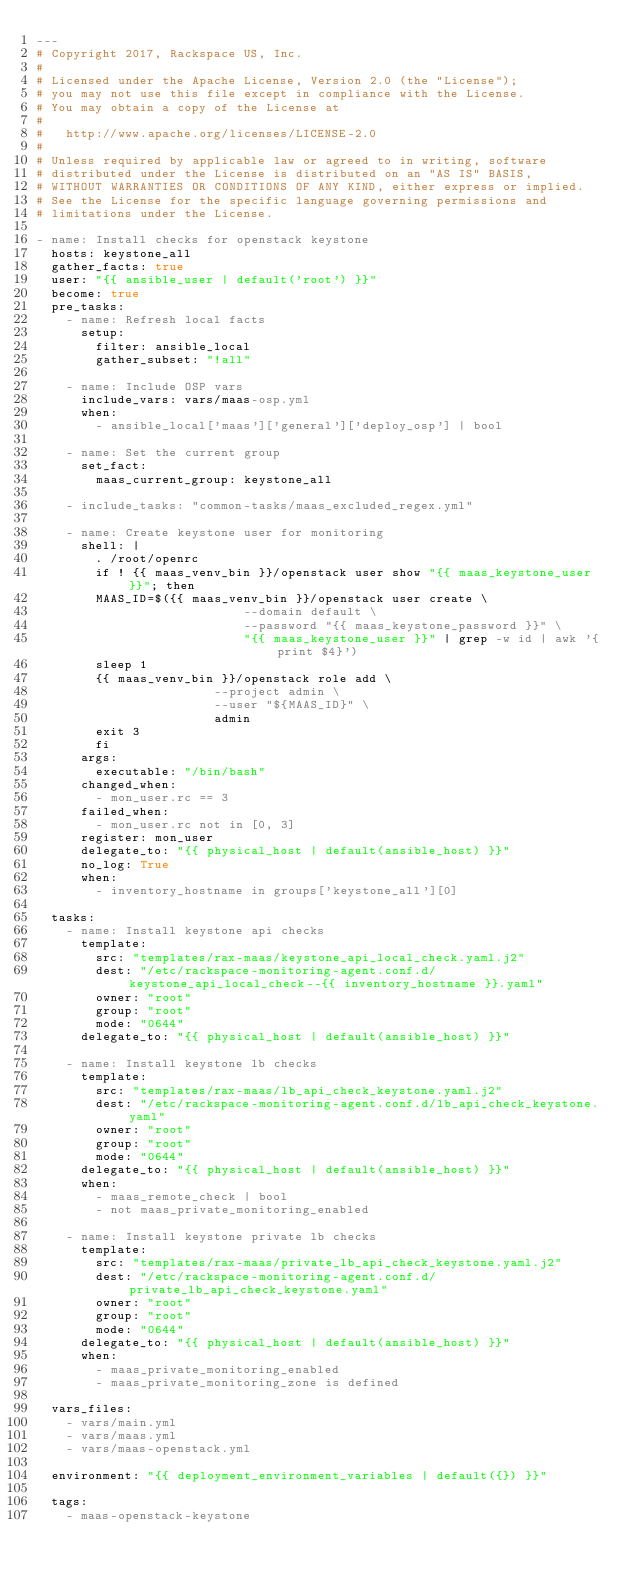Convert code to text. <code><loc_0><loc_0><loc_500><loc_500><_YAML_>---
# Copyright 2017, Rackspace US, Inc.
#
# Licensed under the Apache License, Version 2.0 (the "License");
# you may not use this file except in compliance with the License.
# You may obtain a copy of the License at
#
#   http://www.apache.org/licenses/LICENSE-2.0
#
# Unless required by applicable law or agreed to in writing, software
# distributed under the License is distributed on an "AS IS" BASIS,
# WITHOUT WARRANTIES OR CONDITIONS OF ANY KIND, either express or implied.
# See the License for the specific language governing permissions and
# limitations under the License.

- name: Install checks for openstack keystone
  hosts: keystone_all
  gather_facts: true
  user: "{{ ansible_user | default('root') }}"
  become: true
  pre_tasks:
    - name: Refresh local facts
      setup:
        filter: ansible_local
        gather_subset: "!all"

    - name: Include OSP vars
      include_vars: vars/maas-osp.yml
      when:
        - ansible_local['maas']['general']['deploy_osp'] | bool

    - name: Set the current group
      set_fact:
        maas_current_group: keystone_all

    - include_tasks: "common-tasks/maas_excluded_regex.yml"

    - name: Create keystone user for monitoring
      shell: |
        . /root/openrc
        if ! {{ maas_venv_bin }}/openstack user show "{{ maas_keystone_user }}"; then
        MAAS_ID=$({{ maas_venv_bin }}/openstack user create \
                            --domain default \
                            --password "{{ maas_keystone_password }}" \
                            "{{ maas_keystone_user }}" | grep -w id | awk '{print $4}')
        sleep 1
        {{ maas_venv_bin }}/openstack role add \
                        --project admin \
                        --user "${MAAS_ID}" \
                        admin
        exit 3
        fi
      args:
        executable: "/bin/bash"
      changed_when:
        - mon_user.rc == 3
      failed_when:
        - mon_user.rc not in [0, 3]
      register: mon_user
      delegate_to: "{{ physical_host | default(ansible_host) }}"
      no_log: True
      when:
        - inventory_hostname in groups['keystone_all'][0]

  tasks:
    - name: Install keystone api checks
      template:
        src: "templates/rax-maas/keystone_api_local_check.yaml.j2"
        dest: "/etc/rackspace-monitoring-agent.conf.d/keystone_api_local_check--{{ inventory_hostname }}.yaml"
        owner: "root"
        group: "root"
        mode: "0644"
      delegate_to: "{{ physical_host | default(ansible_host) }}"

    - name: Install keystone lb checks
      template:
        src: "templates/rax-maas/lb_api_check_keystone.yaml.j2"
        dest: "/etc/rackspace-monitoring-agent.conf.d/lb_api_check_keystone.yaml"
        owner: "root"
        group: "root"
        mode: "0644"
      delegate_to: "{{ physical_host | default(ansible_host) }}"
      when:
        - maas_remote_check | bool
        - not maas_private_monitoring_enabled

    - name: Install keystone private lb checks
      template:
        src: "templates/rax-maas/private_lb_api_check_keystone.yaml.j2"
        dest: "/etc/rackspace-monitoring-agent.conf.d/private_lb_api_check_keystone.yaml"
        owner: "root"
        group: "root"
        mode: "0644"
      delegate_to: "{{ physical_host | default(ansible_host) }}"
      when:
        - maas_private_monitoring_enabled
        - maas_private_monitoring_zone is defined

  vars_files:
    - vars/main.yml
    - vars/maas.yml
    - vars/maas-openstack.yml

  environment: "{{ deployment_environment_variables | default({}) }}"

  tags:
    - maas-openstack-keystone
</code> 